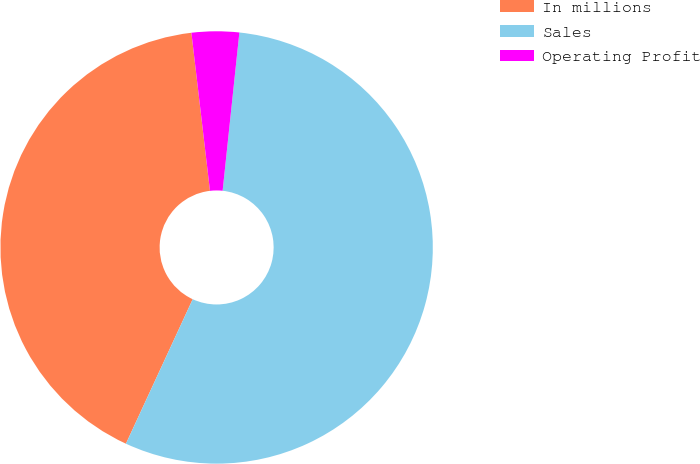Convert chart to OTSL. <chart><loc_0><loc_0><loc_500><loc_500><pie_chart><fcel>In millions<fcel>Sales<fcel>Operating Profit<nl><fcel>41.25%<fcel>55.21%<fcel>3.54%<nl></chart> 